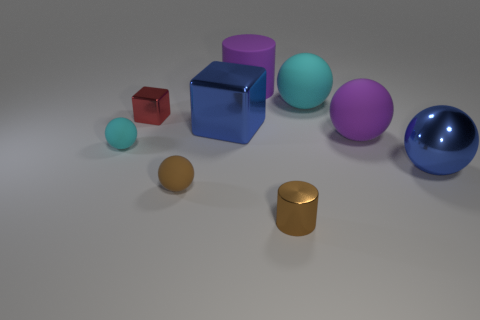There is a purple cylinder that is the same size as the blue cube; what is it made of?
Offer a very short reply. Rubber. Is there a small blue block that has the same material as the purple ball?
Offer a terse response. No. The matte object that is to the right of the brown ball and on the left side of the large cyan ball is what color?
Ensure brevity in your answer.  Purple. How many other things are there of the same color as the tiny cylinder?
Provide a short and direct response. 1. What material is the tiny sphere that is to the right of the object left of the tiny metal thing to the left of the large cylinder?
Keep it short and to the point. Rubber. What number of cylinders are tiny objects or cyan things?
Your answer should be compact. 1. Are there any other things that have the same size as the brown sphere?
Keep it short and to the point. Yes. How many cyan things are in front of the tiny rubber thing behind the blue object that is on the right side of the matte cylinder?
Keep it short and to the point. 0. Is the small cyan thing the same shape as the small brown rubber object?
Make the answer very short. Yes. Do the blue thing left of the blue sphere and the tiny brown thing behind the shiny cylinder have the same material?
Offer a terse response. No. 